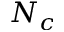Convert formula to latex. <formula><loc_0><loc_0><loc_500><loc_500>N _ { c }</formula> 